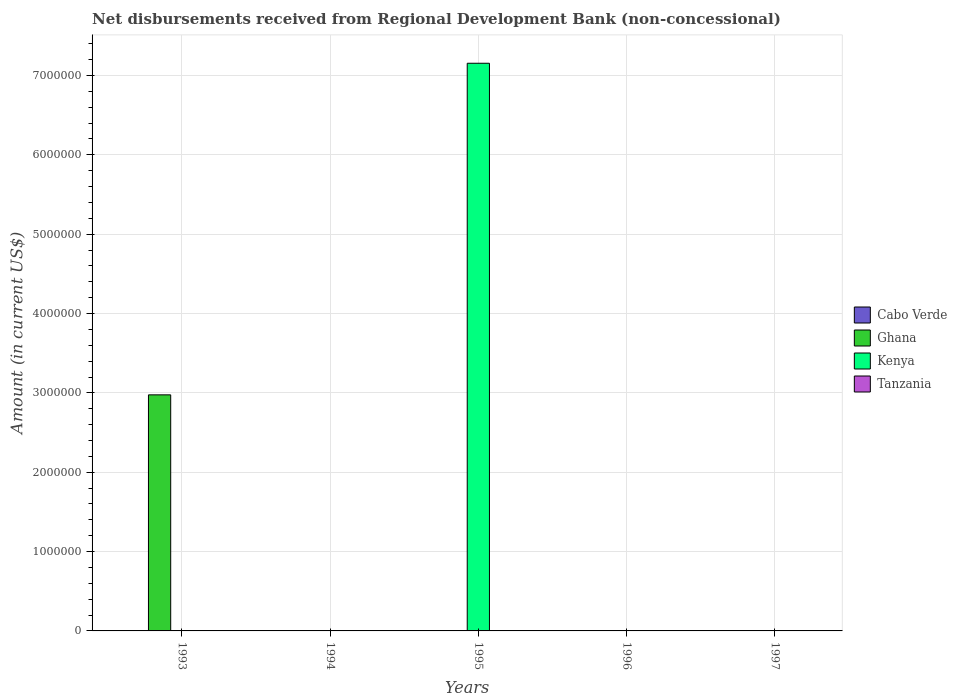How many bars are there on the 3rd tick from the left?
Ensure brevity in your answer.  1. How many bars are there on the 5th tick from the right?
Provide a succinct answer. 1. What is the label of the 5th group of bars from the left?
Provide a succinct answer. 1997. What is the amount of disbursements received from Regional Development Bank in Cabo Verde in 1997?
Keep it short and to the point. 0. Across all years, what is the maximum amount of disbursements received from Regional Development Bank in Kenya?
Offer a terse response. 7.15e+06. What is the total amount of disbursements received from Regional Development Bank in Kenya in the graph?
Give a very brief answer. 7.15e+06. What is the difference between the amount of disbursements received from Regional Development Bank in Cabo Verde in 1997 and the amount of disbursements received from Regional Development Bank in Tanzania in 1996?
Your answer should be very brief. 0. What is the difference between the highest and the lowest amount of disbursements received from Regional Development Bank in Ghana?
Provide a short and direct response. 2.98e+06. In how many years, is the amount of disbursements received from Regional Development Bank in Tanzania greater than the average amount of disbursements received from Regional Development Bank in Tanzania taken over all years?
Ensure brevity in your answer.  0. Is it the case that in every year, the sum of the amount of disbursements received from Regional Development Bank in Kenya and amount of disbursements received from Regional Development Bank in Cabo Verde is greater than the sum of amount of disbursements received from Regional Development Bank in Ghana and amount of disbursements received from Regional Development Bank in Tanzania?
Provide a succinct answer. No. How many years are there in the graph?
Make the answer very short. 5. Are the values on the major ticks of Y-axis written in scientific E-notation?
Your answer should be very brief. No. Does the graph contain any zero values?
Provide a short and direct response. Yes. How are the legend labels stacked?
Provide a succinct answer. Vertical. What is the title of the graph?
Keep it short and to the point. Net disbursements received from Regional Development Bank (non-concessional). What is the label or title of the Y-axis?
Make the answer very short. Amount (in current US$). What is the Amount (in current US$) of Cabo Verde in 1993?
Your answer should be compact. 0. What is the Amount (in current US$) in Ghana in 1993?
Your response must be concise. 2.98e+06. What is the Amount (in current US$) of Kenya in 1993?
Provide a succinct answer. 0. What is the Amount (in current US$) in Tanzania in 1993?
Your response must be concise. 0. What is the Amount (in current US$) in Cabo Verde in 1994?
Provide a short and direct response. 0. What is the Amount (in current US$) of Tanzania in 1994?
Keep it short and to the point. 0. What is the Amount (in current US$) in Kenya in 1995?
Offer a very short reply. 7.15e+06. What is the Amount (in current US$) in Tanzania in 1995?
Your answer should be compact. 0. What is the Amount (in current US$) in Cabo Verde in 1996?
Give a very brief answer. 0. What is the Amount (in current US$) in Ghana in 1996?
Provide a short and direct response. 0. What is the Amount (in current US$) of Tanzania in 1996?
Provide a short and direct response. 0. What is the Amount (in current US$) in Kenya in 1997?
Give a very brief answer. 0. What is the Amount (in current US$) of Tanzania in 1997?
Keep it short and to the point. 0. Across all years, what is the maximum Amount (in current US$) of Ghana?
Make the answer very short. 2.98e+06. Across all years, what is the maximum Amount (in current US$) of Kenya?
Your response must be concise. 7.15e+06. Across all years, what is the minimum Amount (in current US$) in Ghana?
Offer a very short reply. 0. Across all years, what is the minimum Amount (in current US$) of Kenya?
Your answer should be very brief. 0. What is the total Amount (in current US$) in Ghana in the graph?
Your response must be concise. 2.98e+06. What is the total Amount (in current US$) in Kenya in the graph?
Make the answer very short. 7.15e+06. What is the difference between the Amount (in current US$) in Ghana in 1993 and the Amount (in current US$) in Kenya in 1995?
Provide a succinct answer. -4.18e+06. What is the average Amount (in current US$) in Ghana per year?
Provide a short and direct response. 5.95e+05. What is the average Amount (in current US$) in Kenya per year?
Your answer should be compact. 1.43e+06. What is the difference between the highest and the lowest Amount (in current US$) in Ghana?
Offer a very short reply. 2.98e+06. What is the difference between the highest and the lowest Amount (in current US$) of Kenya?
Ensure brevity in your answer.  7.15e+06. 